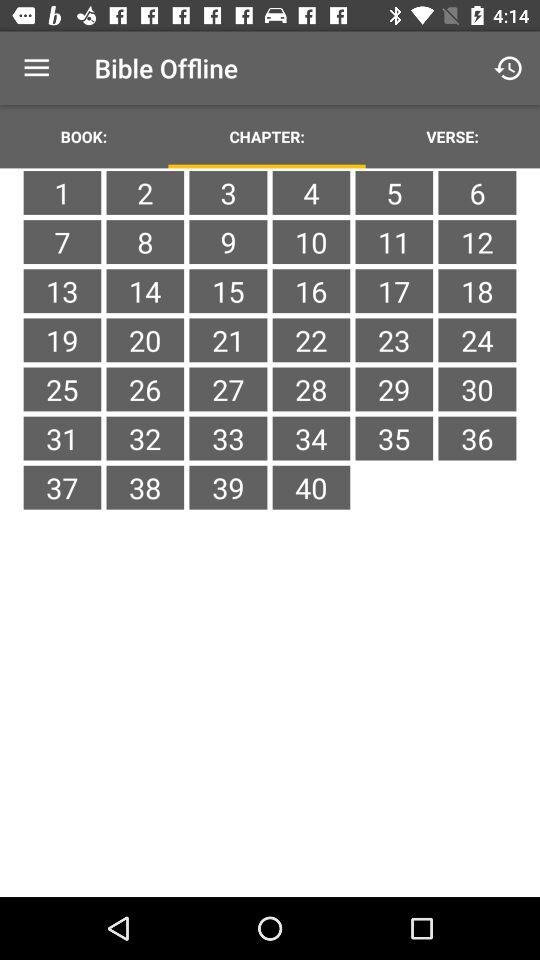What is the application name? The application name is "Bible Offline". 